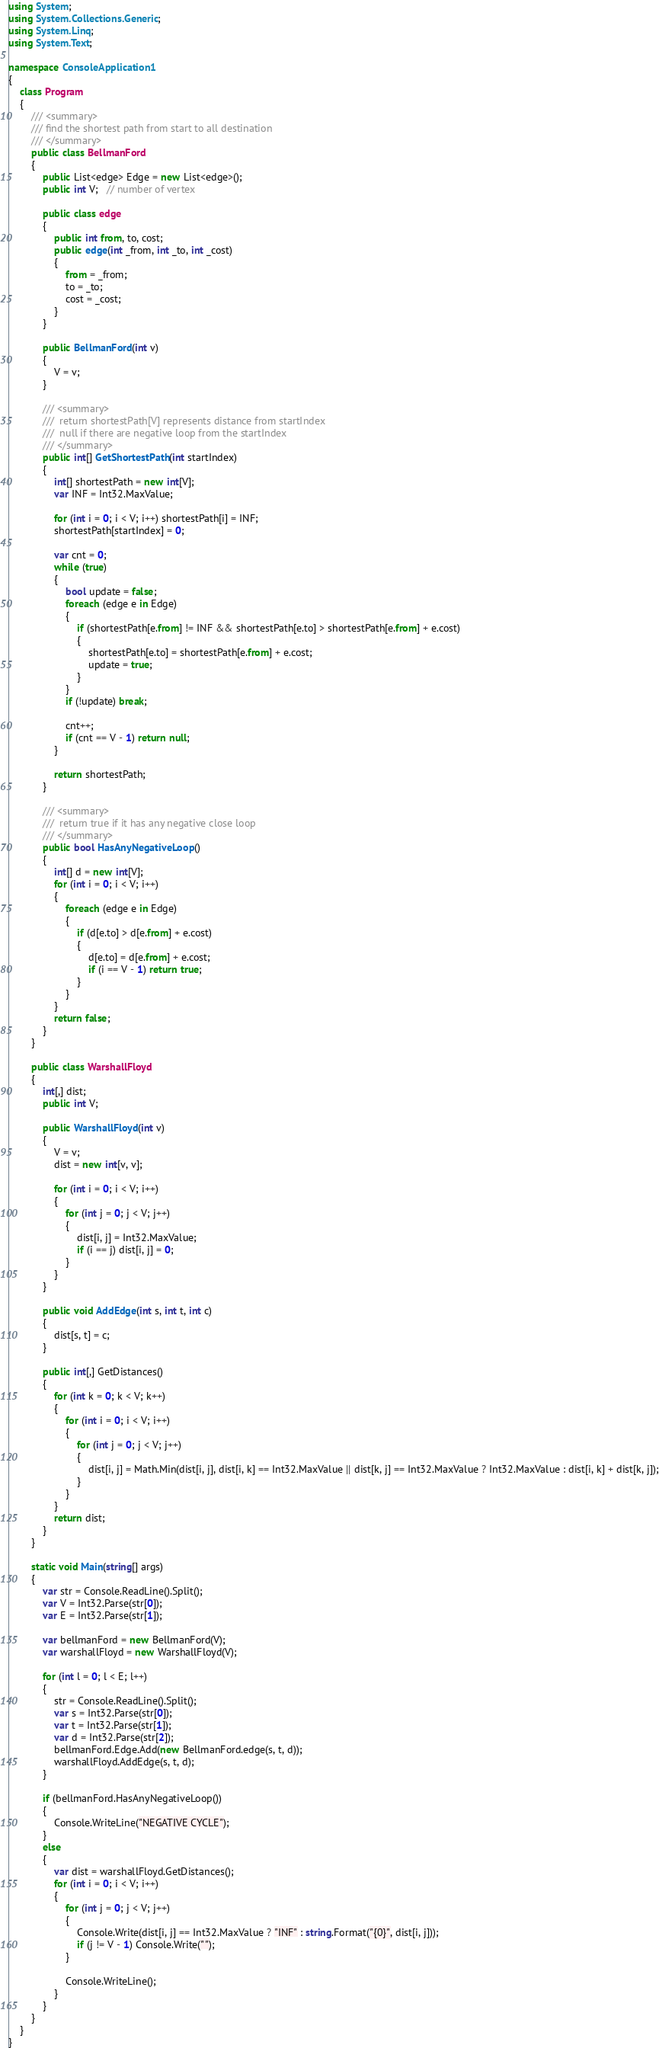Convert code to text. <code><loc_0><loc_0><loc_500><loc_500><_C#_>using System;
using System.Collections.Generic;
using System.Linq;
using System.Text;

namespace ConsoleApplication1
{
    class Program
    {
        /// <summary>
        /// find the shortest path from start to all destination
        /// </summary>
        public class BellmanFord
        {
            public List<edge> Edge = new List<edge>();
            public int V;   // number of vertex

            public class edge
            {
                public int from, to, cost;
                public edge(int _from, int _to, int _cost)
                {
                    from = _from;
                    to = _to;
                    cost = _cost;
                }
            }

            public BellmanFord(int v)
            {
                V = v;
            }

            /// <summary>
            ///  return shortestPath[V] represents distance from startIndex
            ///  null if there are negative loop from the startIndex
            /// </summary>
            public int[] GetShortestPath(int startIndex)
            {
                int[] shortestPath = new int[V];
                var INF = Int32.MaxValue;

                for (int i = 0; i < V; i++) shortestPath[i] = INF;
                shortestPath[startIndex] = 0;

                var cnt = 0;
                while (true)
                {
                    bool update = false;
                    foreach (edge e in Edge)
                    {
                        if (shortestPath[e.from] != INF && shortestPath[e.to] > shortestPath[e.from] + e.cost)
                        {
                            shortestPath[e.to] = shortestPath[e.from] + e.cost;
                            update = true;
                        }
                    }
                    if (!update) break;

                    cnt++;
                    if (cnt == V - 1) return null;
                }

                return shortestPath;
            }

            /// <summary>
            ///  return true if it has any negative close loop
            /// </summary>
            public bool HasAnyNegativeLoop()
            {
                int[] d = new int[V];
                for (int i = 0; i < V; i++)
                {
                    foreach (edge e in Edge)
                    {
                        if (d[e.to] > d[e.from] + e.cost)
                        {
                            d[e.to] = d[e.from] + e.cost;
                            if (i == V - 1) return true;
                        }
                    }
                }
                return false;
            }
        }

        public class WarshallFloyd
        {
            int[,] dist;
            public int V;

            public WarshallFloyd(int v)
            {
                V = v;
                dist = new int[v, v];

                for (int i = 0; i < V; i++)
                {
                    for (int j = 0; j < V; j++)
                    {
                        dist[i, j] = Int32.MaxValue;
                        if (i == j) dist[i, j] = 0;
                    }
                }
            }

            public void AddEdge(int s, int t, int c)
            {
                dist[s, t] = c;
            }

            public int[,] GetDistances()
            {
                for (int k = 0; k < V; k++)
                {
                    for (int i = 0; i < V; i++)
                    {
                        for (int j = 0; j < V; j++)
                        {
                            dist[i, j] = Math.Min(dist[i, j], dist[i, k] == Int32.MaxValue || dist[k, j] == Int32.MaxValue ? Int32.MaxValue : dist[i, k] + dist[k, j]);
                        }
                    }
                }
                return dist;
            }
        }

        static void Main(string[] args)
        {
            var str = Console.ReadLine().Split();
            var V = Int32.Parse(str[0]);
            var E = Int32.Parse(str[1]);

            var bellmanFord = new BellmanFord(V);
            var warshallFloyd = new WarshallFloyd(V);

            for (int l = 0; l < E; l++)
            {
                str = Console.ReadLine().Split();
                var s = Int32.Parse(str[0]);
                var t = Int32.Parse(str[1]);
                var d = Int32.Parse(str[2]);
                bellmanFord.Edge.Add(new BellmanFord.edge(s, t, d));
                warshallFloyd.AddEdge(s, t, d);
            }

            if (bellmanFord.HasAnyNegativeLoop())
            {
                Console.WriteLine("NEGATIVE CYCLE");
            }
            else
            {
                var dist = warshallFloyd.GetDistances();
                for (int i = 0; i < V; i++)
                {
                    for (int j = 0; j < V; j++)
                    {
                        Console.Write(dist[i, j] == Int32.MaxValue ? "INF" : string.Format("{0}", dist[i, j]));
                        if (j != V - 1) Console.Write(" ");
                    }

                    Console.WriteLine();
                }
            }
        }
    }
}</code> 